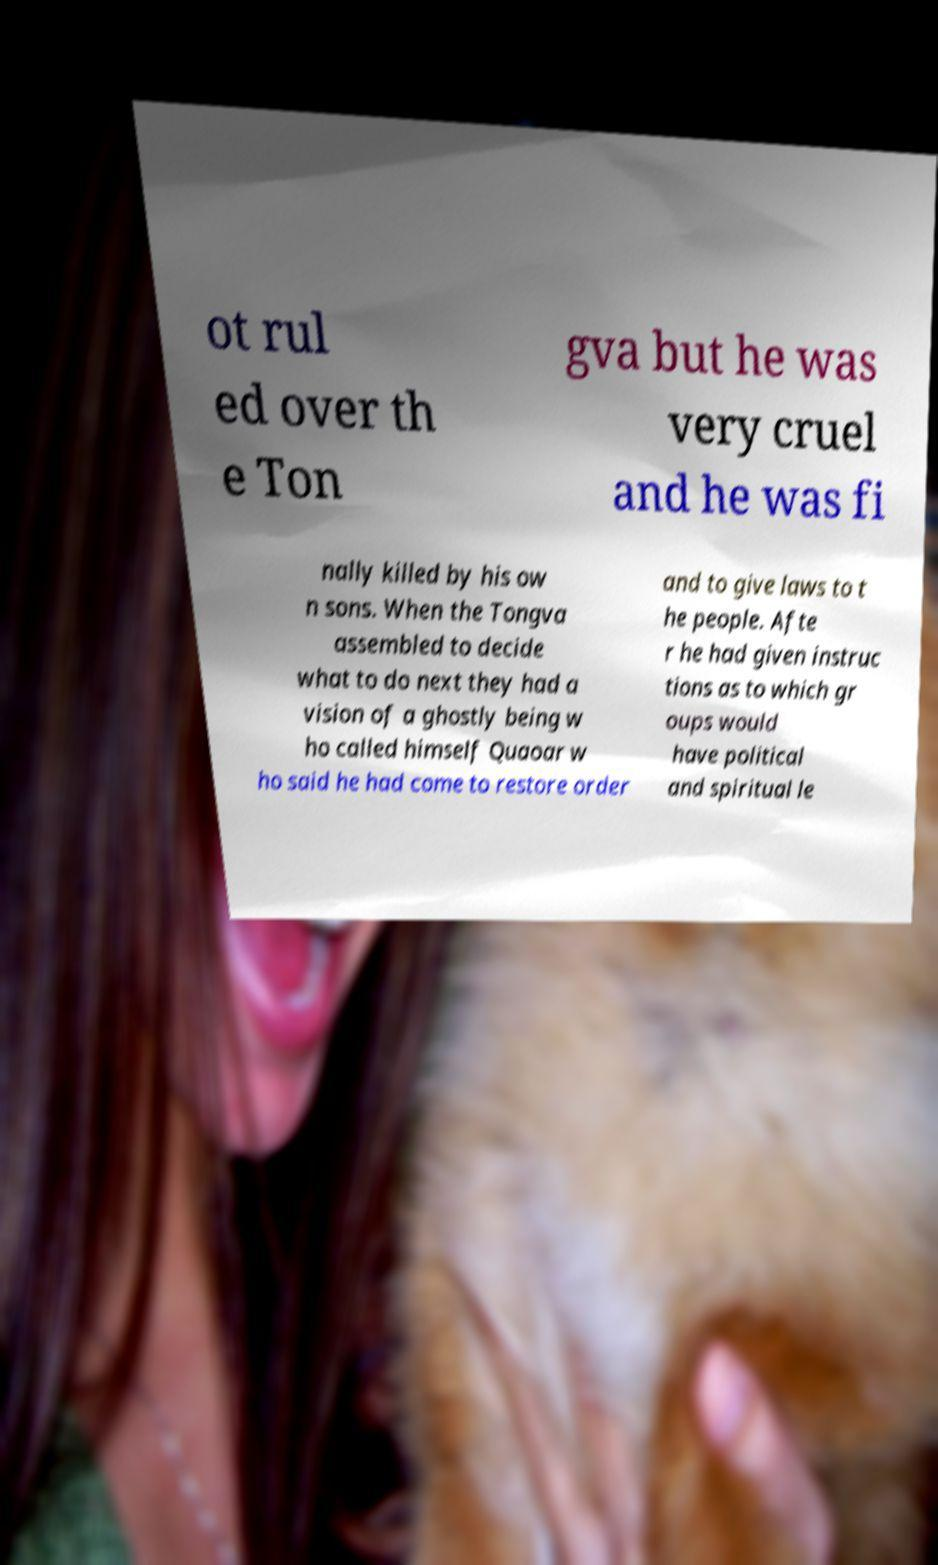Can you read and provide the text displayed in the image?This photo seems to have some interesting text. Can you extract and type it out for me? ot rul ed over th e Ton gva but he was very cruel and he was fi nally killed by his ow n sons. When the Tongva assembled to decide what to do next they had a vision of a ghostly being w ho called himself Quaoar w ho said he had come to restore order and to give laws to t he people. Afte r he had given instruc tions as to which gr oups would have political and spiritual le 